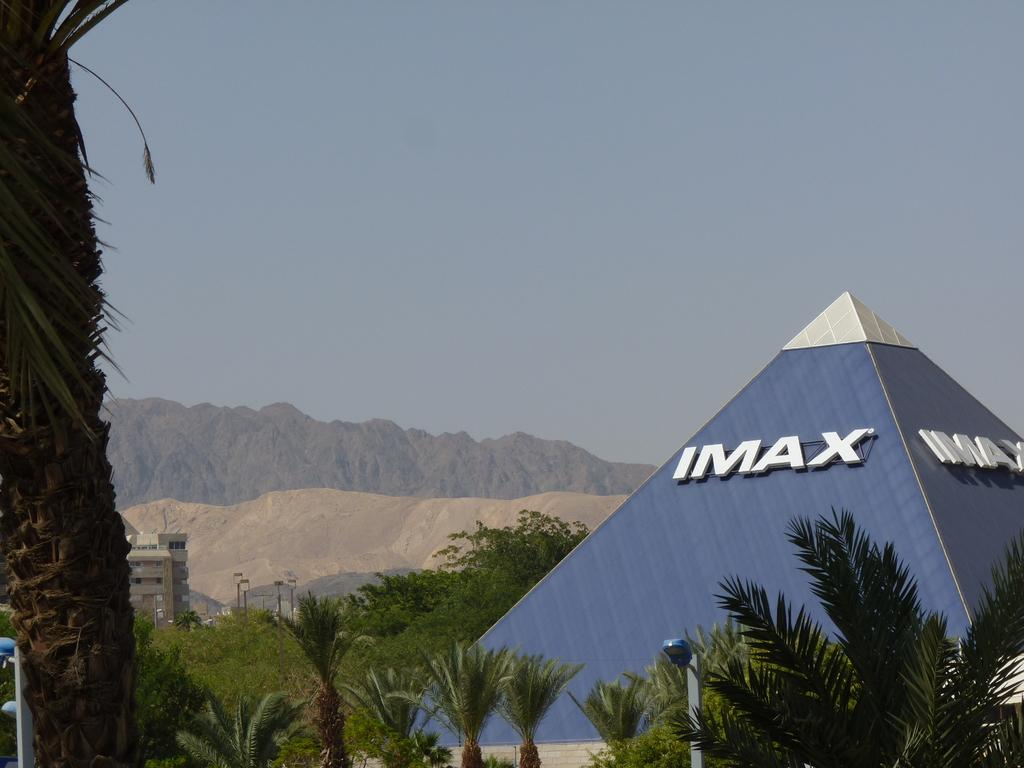How many buildings can be seen in the image? There are two buildings in the image. What is the structure of one of the buildings? One of the buildings has a pyramid structure. What type of natural vegetation is present in the image? There are trees in the image. What type of artificial lighting is visible in the image? There are lights in the image. What type of vertical structures can be seen in the image? There are poles in the image. What type of natural landform is present in the image? There are hills in the image. What is visible in the background of the image? The sky is visible in the background of the image. What type of apparel is the plane wearing in the image? There is no plane present in the image, so it cannot be wearing any apparel. 